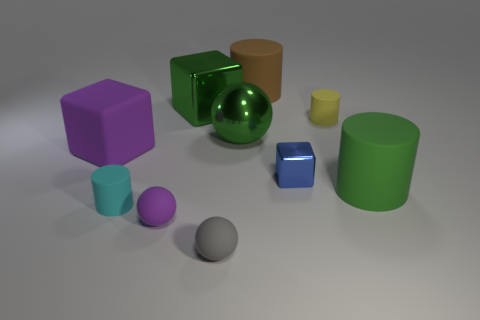Subtract 1 balls. How many balls are left? 2 Subtract all rubber balls. How many balls are left? 1 Subtract all cyan cylinders. How many cylinders are left? 3 Subtract all gray cylinders. Subtract all cyan blocks. How many cylinders are left? 4 Subtract all blocks. How many objects are left? 7 Subtract 1 blue blocks. How many objects are left? 9 Subtract all big yellow rubber cylinders. Subtract all large brown matte objects. How many objects are left? 9 Add 8 tiny cyan matte cylinders. How many tiny cyan matte cylinders are left? 9 Add 8 tiny balls. How many tiny balls exist? 10 